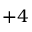Convert formula to latex. <formula><loc_0><loc_0><loc_500><loc_500>+ 4</formula> 